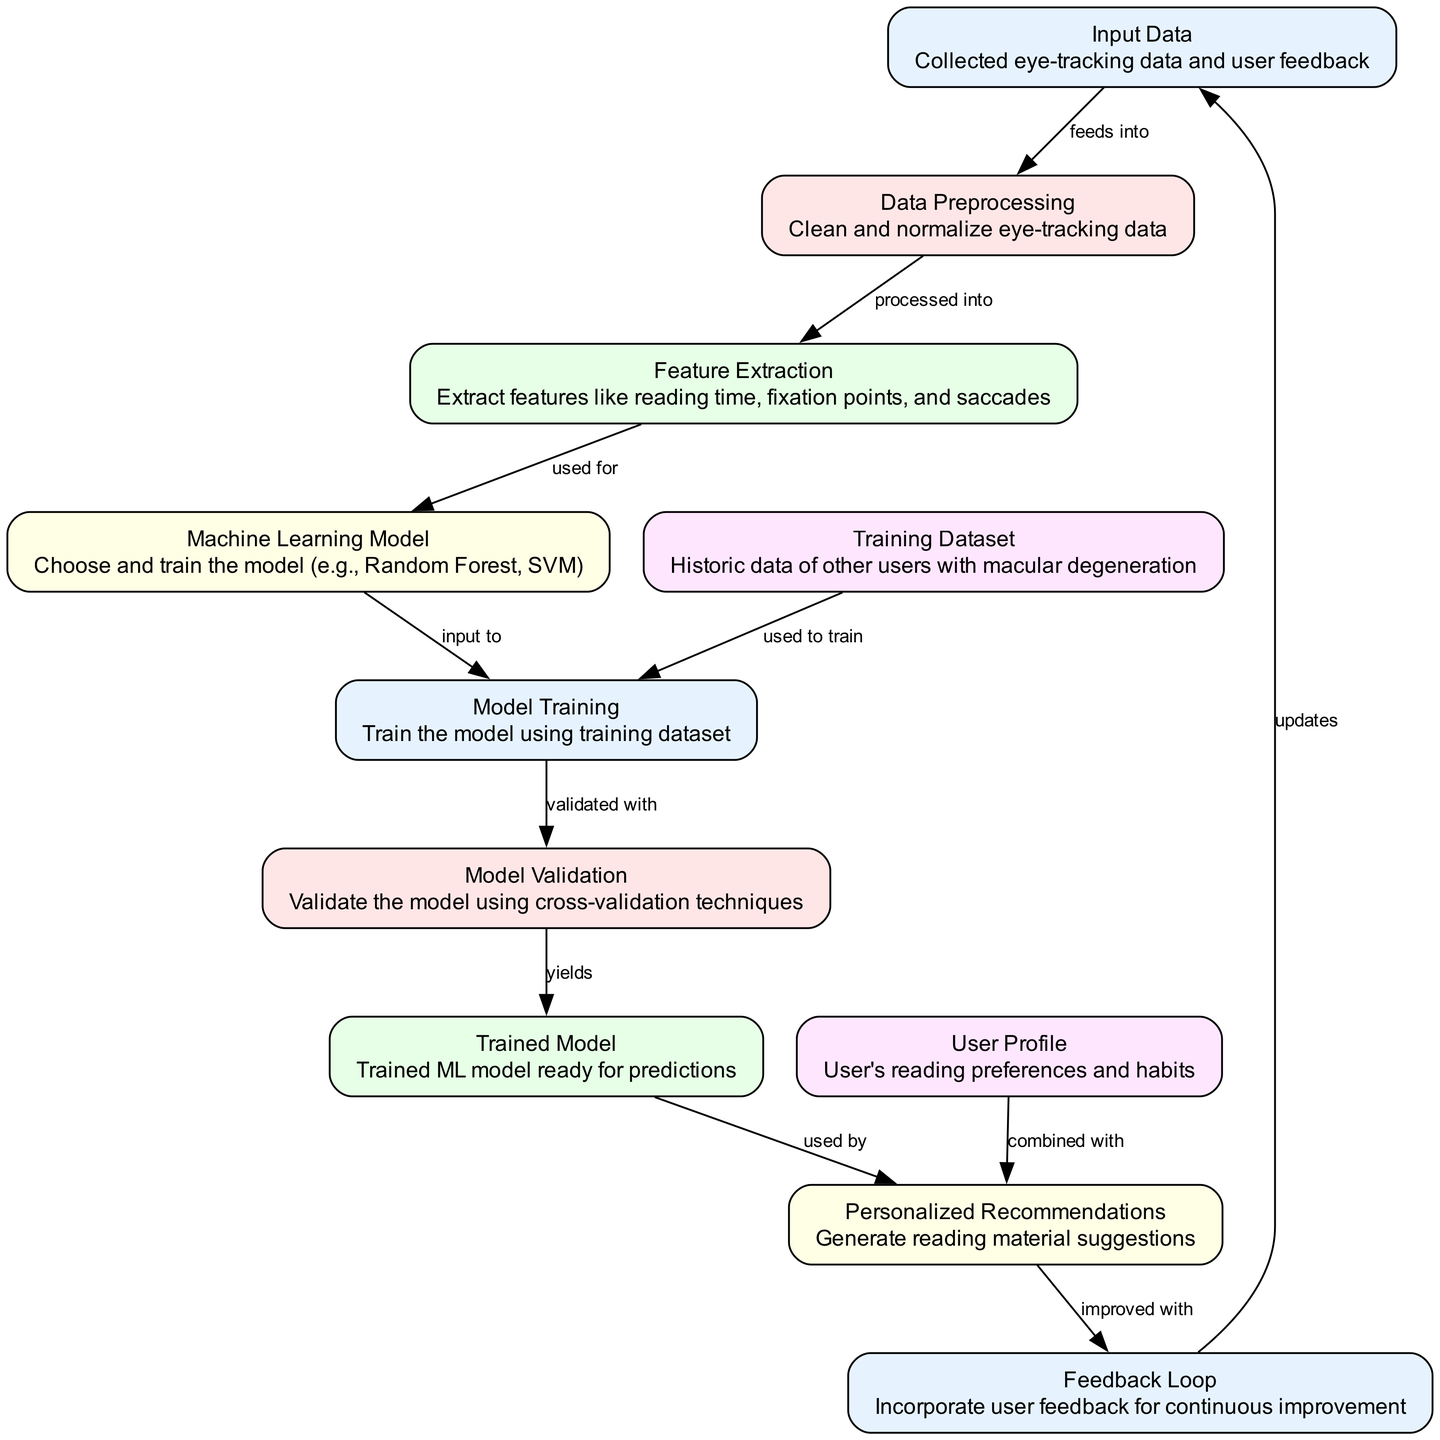What is the first step in the diagram? The first step in the diagram is labeled "Input Data," which contains the collected eye-tracking data and user feedback.
Answer: Input Data How many nodes are in the diagram? The diagram has a total of 11 nodes that represent different components of the machine learning process.
Answer: 11 What do the "Training Dataset" and "Machine Learning Model" nodes connect with? The "Training Dataset" connects to "Model Training" and the "Machine Learning Model" connects to "Model Training" as well, indicating both are inputs for model training.
Answer: Model Training What process comes after "Model Validation"? After "Model Validation," the next process is "Trained Model," meaning that validation yields the trained model ready for predictions.
Answer: Trained Model Which node provides user preferences for generating recommendations? The "User Profile" node provides the user's reading preferences and habits that are combined with the trained model to generate recommendations.
Answer: User Profile How is the trained model used in generating recommendations? The trained model is used together with the "User Profile" to generate personalized recommendations for reading materials.
Answer: Used by What updates the "Feedback Loop"? The "Feedback Loop" is updated by incorporating user feedback to ensure continuous improvement of the system.
Answer: User feedback Which node processes the collected eye-tracking data? The "Data Preprocessing" node processes the collected eye-tracking data by cleaning and normalizing it before further analysis.
Answer: Data Preprocessing How many edges are in the diagram? There are 10 edges in the diagram, showing the relationships and flow of information between the nodes.
Answer: 10 What is the final output of the diagram after all processes? The final output of the diagram is "Personalized Recommendations," which are the generated reading material suggestions based on the analysis and user feedback.
Answer: Personalized Recommendations 